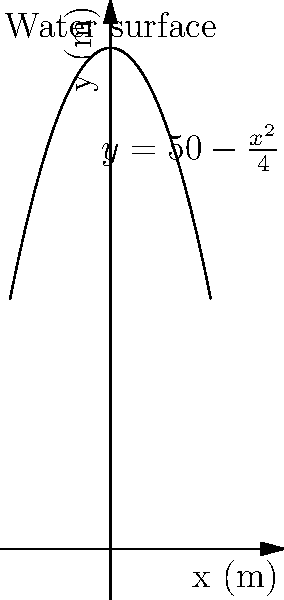As a former city planner, you've been asked to consult on a new water reservoir project. The cross-section of the reservoir can be modeled by the parabola $y=50-\frac{x^2}{4}$, where $x$ and $y$ are measured in meters. If the reservoir is 100 meters long, calculate its volume in cubic meters. To solve this problem, we'll follow these steps:

1) The volume of the reservoir can be calculated using the formula:

   $V = L \int_{-a}^{a} A(x) dx$

   where $L$ is the length of the reservoir, and $A(x)$ is the cross-sectional area at any point $x$.

2) From the given equation, we can see that the parabola intersects the x-axis at $x = \pm 20$ (when $y = 0$). So, $a = 20$.

3) The cross-sectional area $A(x)$ at any point $x$ is:

   $A(x) = \int_{0}^{50-\frac{x^2}{4}} dy = 50 - \frac{x^2}{4}$

4) Now, we can set up our volume integral:

   $V = 100 \int_{-20}^{20} (50 - \frac{x^2}{4}) dx$

5) Evaluating the integral:

   $V = 100 [50x - \frac{x^3}{12}]_{-20}^{20}$

6) Substituting the limits:

   $V = 100 [(50(20) - \frac{20^3}{12}) - (50(-20) - \frac{(-20)^3}{12})]$
   
   $V = 100 [(1000 - \frac{8000}{12}) - (-1000 - \frac{-8000}{12})]$
   
   $V = 100 [(1000 - \frac{2000}{3}) - (-1000 + \frac{2000}{3})]$
   
   $V = 100 [(\frac{3000}{3} - \frac{2000}{3}) - (-\frac{3000}{3} + \frac{2000}{3})]$
   
   $V = 100 [\frac{1000}{3} + \frac{5000}{3}]$
   
   $V = 100 \cdot \frac{6000}{3} = 200,000$

Therefore, the volume of the reservoir is 200,000 cubic meters.
Answer: 200,000 m³ 